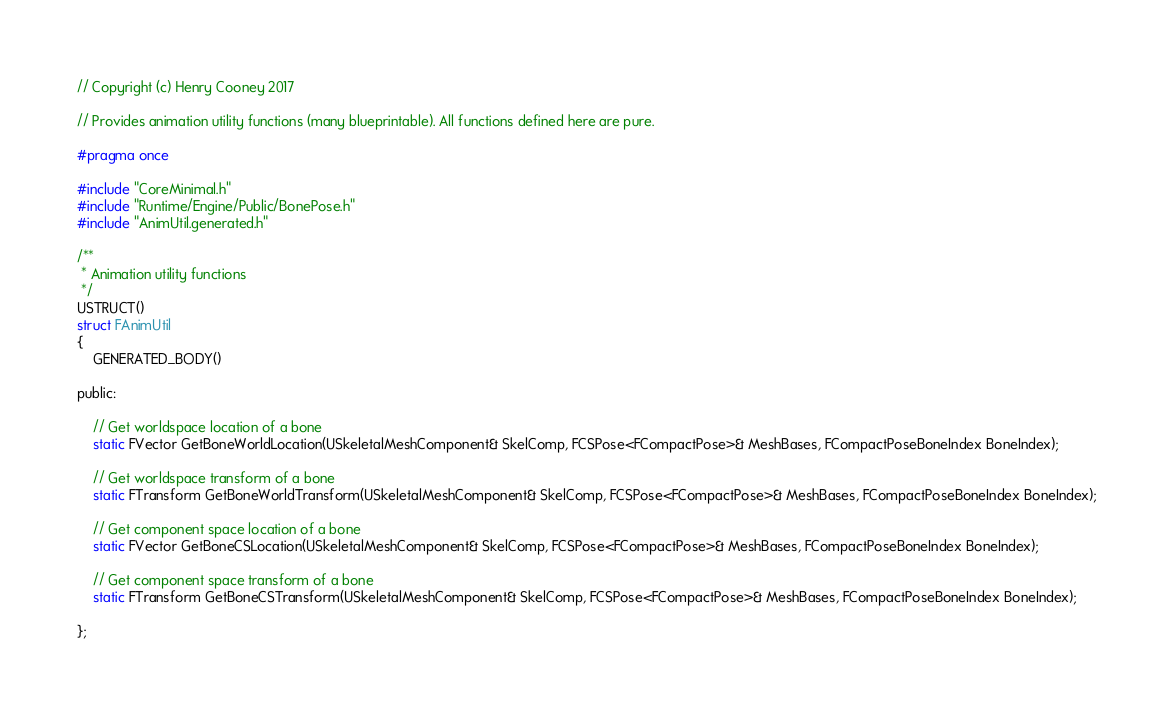Convert code to text. <code><loc_0><loc_0><loc_500><loc_500><_C_>// Copyright (c) Henry Cooney 2017

// Provides animation utility functions (many blueprintable). All functions defined here are pure.

#pragma once

#include "CoreMinimal.h"
#include "Runtime/Engine/Public/BonePose.h"
#include "AnimUtil.generated.h"

/**
 * Animation utility functions
 */
USTRUCT()
struct FAnimUtil 
{
	GENERATED_BODY()
	
public:

	// Get worldspace location of a bone
	static FVector GetBoneWorldLocation(USkeletalMeshComponent& SkelComp, FCSPose<FCompactPose>& MeshBases, FCompactPoseBoneIndex BoneIndex);

	// Get worldspace transform of a bone
	static FTransform GetBoneWorldTransform(USkeletalMeshComponent& SkelComp, FCSPose<FCompactPose>& MeshBases, FCompactPoseBoneIndex BoneIndex);

	// Get component space location of a bone
	static FVector GetBoneCSLocation(USkeletalMeshComponent& SkelComp, FCSPose<FCompactPose>& MeshBases, FCompactPoseBoneIndex BoneIndex);

	// Get component space transform of a bone
	static FTransform GetBoneCSTransform(USkeletalMeshComponent& SkelComp, FCSPose<FCompactPose>& MeshBases, FCompactPoseBoneIndex BoneIndex);

};
</code> 